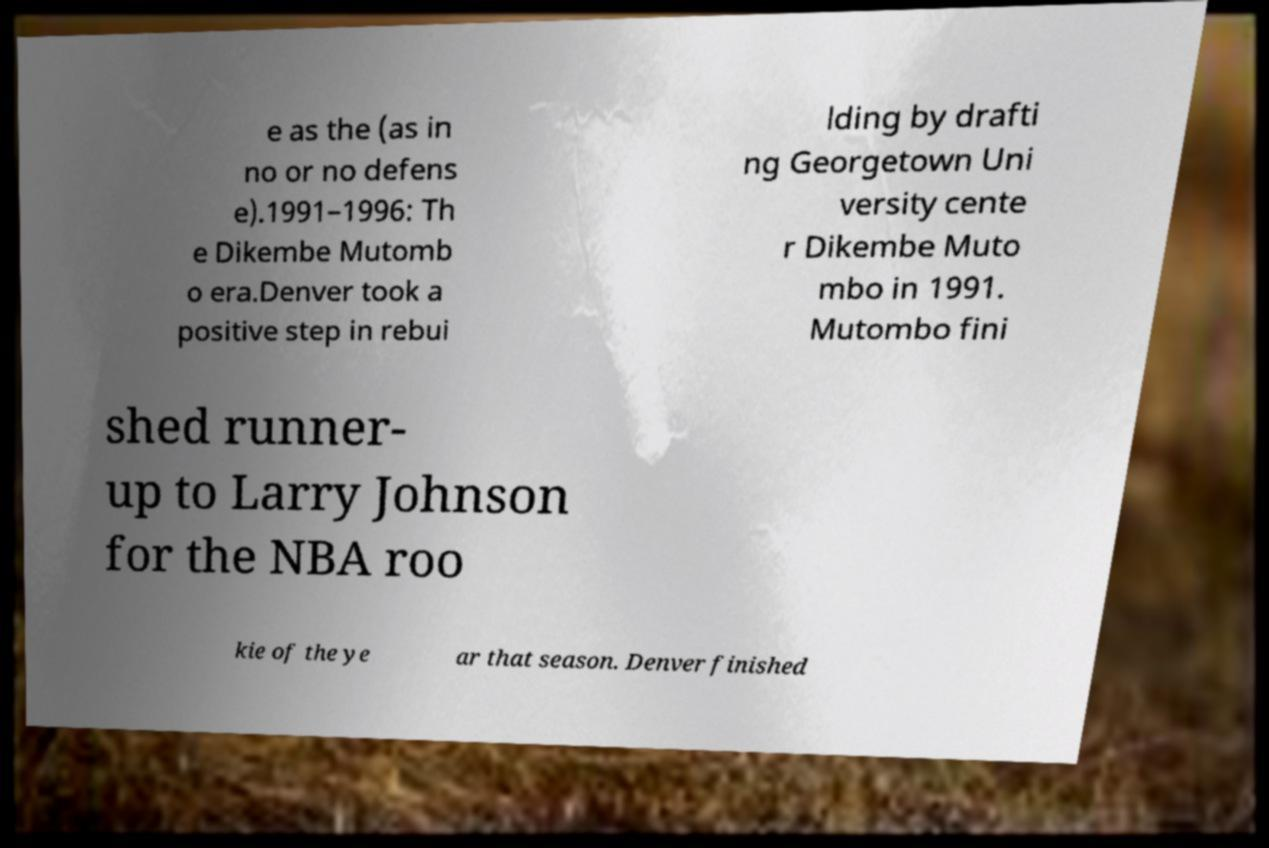Please identify and transcribe the text found in this image. e as the (as in no or no defens e).1991–1996: Th e Dikembe Mutomb o era.Denver took a positive step in rebui lding by drafti ng Georgetown Uni versity cente r Dikembe Muto mbo in 1991. Mutombo fini shed runner- up to Larry Johnson for the NBA roo kie of the ye ar that season. Denver finished 